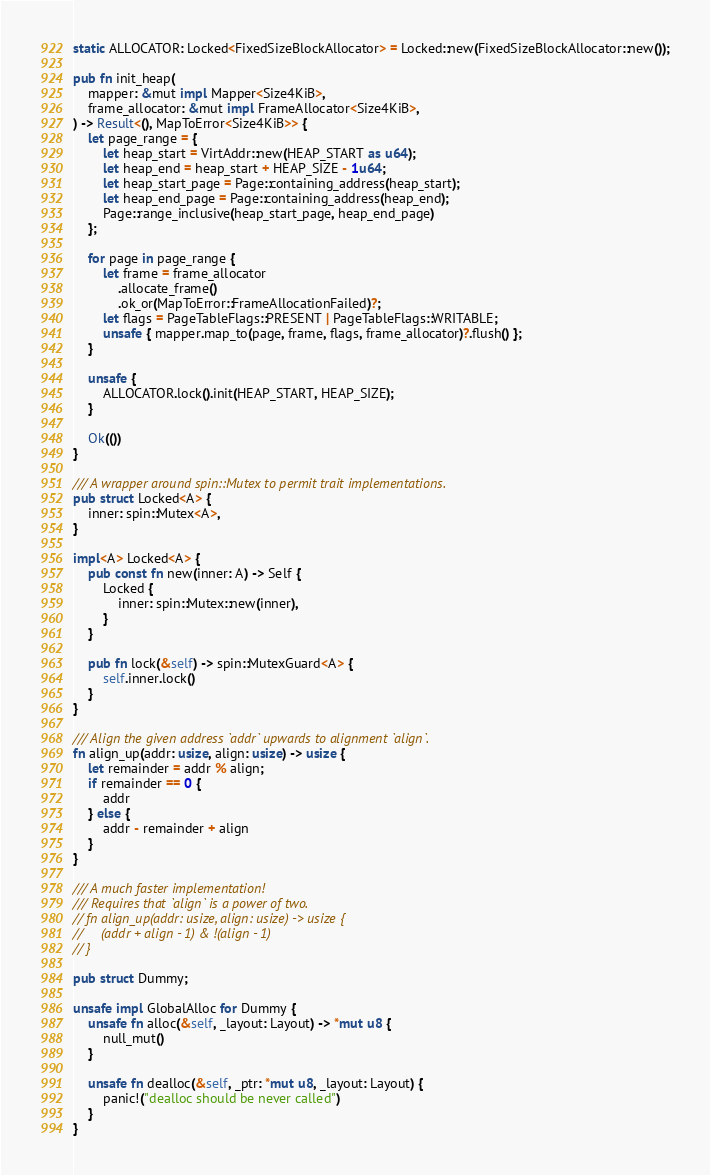Convert code to text. <code><loc_0><loc_0><loc_500><loc_500><_Rust_>static ALLOCATOR: Locked<FixedSizeBlockAllocator> = Locked::new(FixedSizeBlockAllocator::new());

pub fn init_heap(
    mapper: &mut impl Mapper<Size4KiB>,
    frame_allocator: &mut impl FrameAllocator<Size4KiB>,
) -> Result<(), MapToError<Size4KiB>> {
    let page_range = {
        let heap_start = VirtAddr::new(HEAP_START as u64);
        let heap_end = heap_start + HEAP_SIZE - 1u64;
        let heap_start_page = Page::containing_address(heap_start);
        let heap_end_page = Page::containing_address(heap_end);
        Page::range_inclusive(heap_start_page, heap_end_page)
    };

    for page in page_range {
        let frame = frame_allocator
            .allocate_frame()
            .ok_or(MapToError::FrameAllocationFailed)?;
        let flags = PageTableFlags::PRESENT | PageTableFlags::WRITABLE;
        unsafe { mapper.map_to(page, frame, flags, frame_allocator)?.flush() };
    }

    unsafe {
        ALLOCATOR.lock().init(HEAP_START, HEAP_SIZE);
    }

    Ok(())
}

/// A wrapper around spin::Mutex to permit trait implementations.
pub struct Locked<A> {
    inner: spin::Mutex<A>,
}

impl<A> Locked<A> {
    pub const fn new(inner: A) -> Self {
        Locked {
            inner: spin::Mutex::new(inner),
        }
    }

    pub fn lock(&self) -> spin::MutexGuard<A> {
        self.inner.lock()
    }
}

/// Align the given address `addr` upwards to alignment `align`.
fn align_up(addr: usize, align: usize) -> usize {
    let remainder = addr % align;
    if remainder == 0 {
        addr
    } else {
        addr - remainder + align
    }
}

/// A much faster implementation!
/// Requires that `align` is a power of two.
// fn align_up(addr: usize, align: usize) -> usize {
//     (addr + align - 1) & !(align - 1)
// }

pub struct Dummy;

unsafe impl GlobalAlloc for Dummy {
    unsafe fn alloc(&self, _layout: Layout) -> *mut u8 {
        null_mut()
    }

    unsafe fn dealloc(&self, _ptr: *mut u8, _layout: Layout) {
        panic!("dealloc should be never called")
    }
}
</code> 